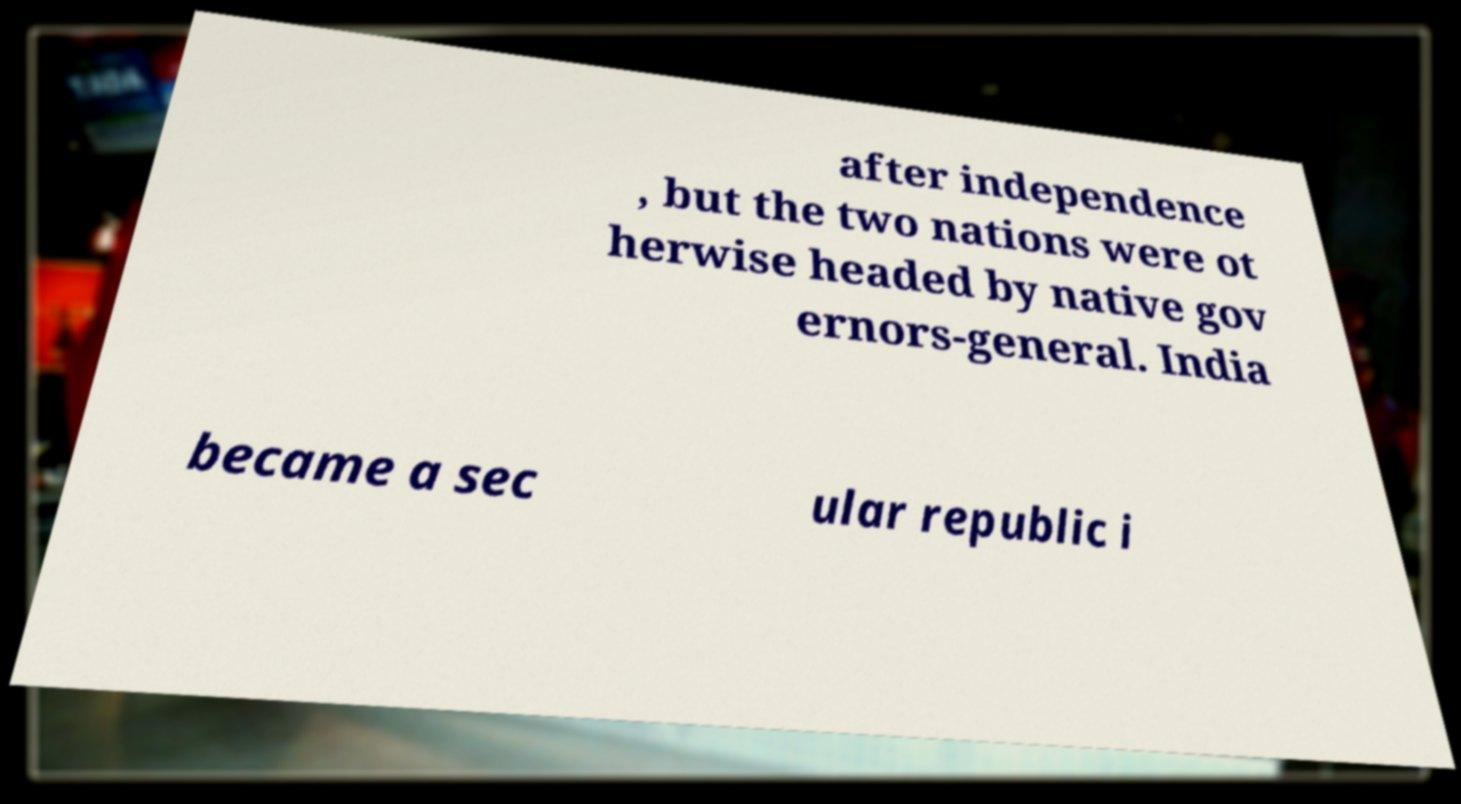Can you accurately transcribe the text from the provided image for me? after independence , but the two nations were ot herwise headed by native gov ernors-general. India became a sec ular republic i 